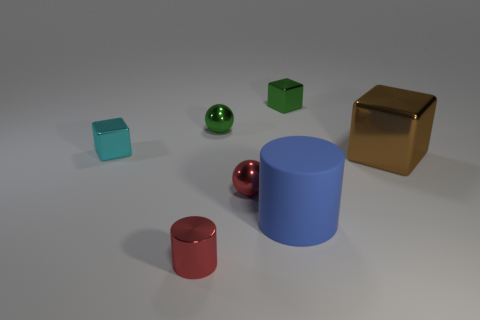There is a tiny thing that is the same color as the shiny cylinder; what is its material?
Provide a succinct answer. Metal. What shape is the brown thing that is the same material as the cyan cube?
Ensure brevity in your answer.  Cube. What shape is the tiny green metal thing that is on the right side of the ball that is in front of the cyan shiny thing?
Your answer should be compact. Cube. There is a tiny red metal object on the left side of the small green sphere; what shape is it?
Make the answer very short. Cylinder. Does the cube behind the cyan block have the same color as the tiny shiny ball behind the cyan metal thing?
Provide a succinct answer. Yes. How many things are left of the big matte object and in front of the small red metallic ball?
Your response must be concise. 1. The green sphere that is the same material as the large block is what size?
Keep it short and to the point. Small. The matte thing is what size?
Your answer should be very brief. Large. What material is the big blue object?
Your answer should be compact. Rubber. There is a sphere in front of the brown metal block; does it have the same size as the tiny green shiny block?
Make the answer very short. Yes. 